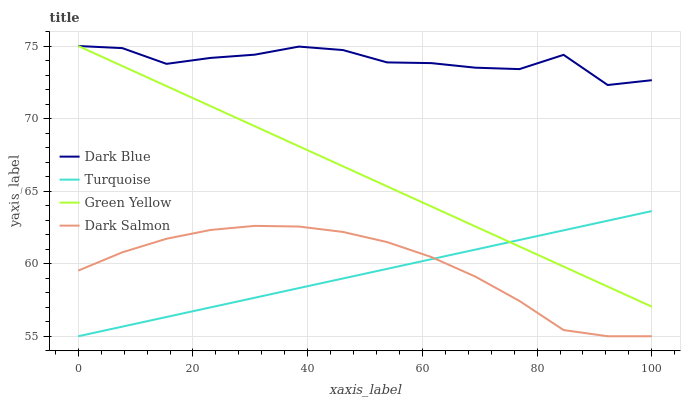Does Turquoise have the minimum area under the curve?
Answer yes or no. Yes. Does Dark Blue have the maximum area under the curve?
Answer yes or no. Yes. Does Green Yellow have the minimum area under the curve?
Answer yes or no. No. Does Green Yellow have the maximum area under the curve?
Answer yes or no. No. Is Turquoise the smoothest?
Answer yes or no. Yes. Is Dark Blue the roughest?
Answer yes or no. Yes. Is Green Yellow the smoothest?
Answer yes or no. No. Is Green Yellow the roughest?
Answer yes or no. No. Does Turquoise have the lowest value?
Answer yes or no. Yes. Does Green Yellow have the lowest value?
Answer yes or no. No. Does Green Yellow have the highest value?
Answer yes or no. Yes. Does Turquoise have the highest value?
Answer yes or no. No. Is Dark Salmon less than Green Yellow?
Answer yes or no. Yes. Is Green Yellow greater than Dark Salmon?
Answer yes or no. Yes. Does Dark Blue intersect Green Yellow?
Answer yes or no. Yes. Is Dark Blue less than Green Yellow?
Answer yes or no. No. Is Dark Blue greater than Green Yellow?
Answer yes or no. No. Does Dark Salmon intersect Green Yellow?
Answer yes or no. No. 